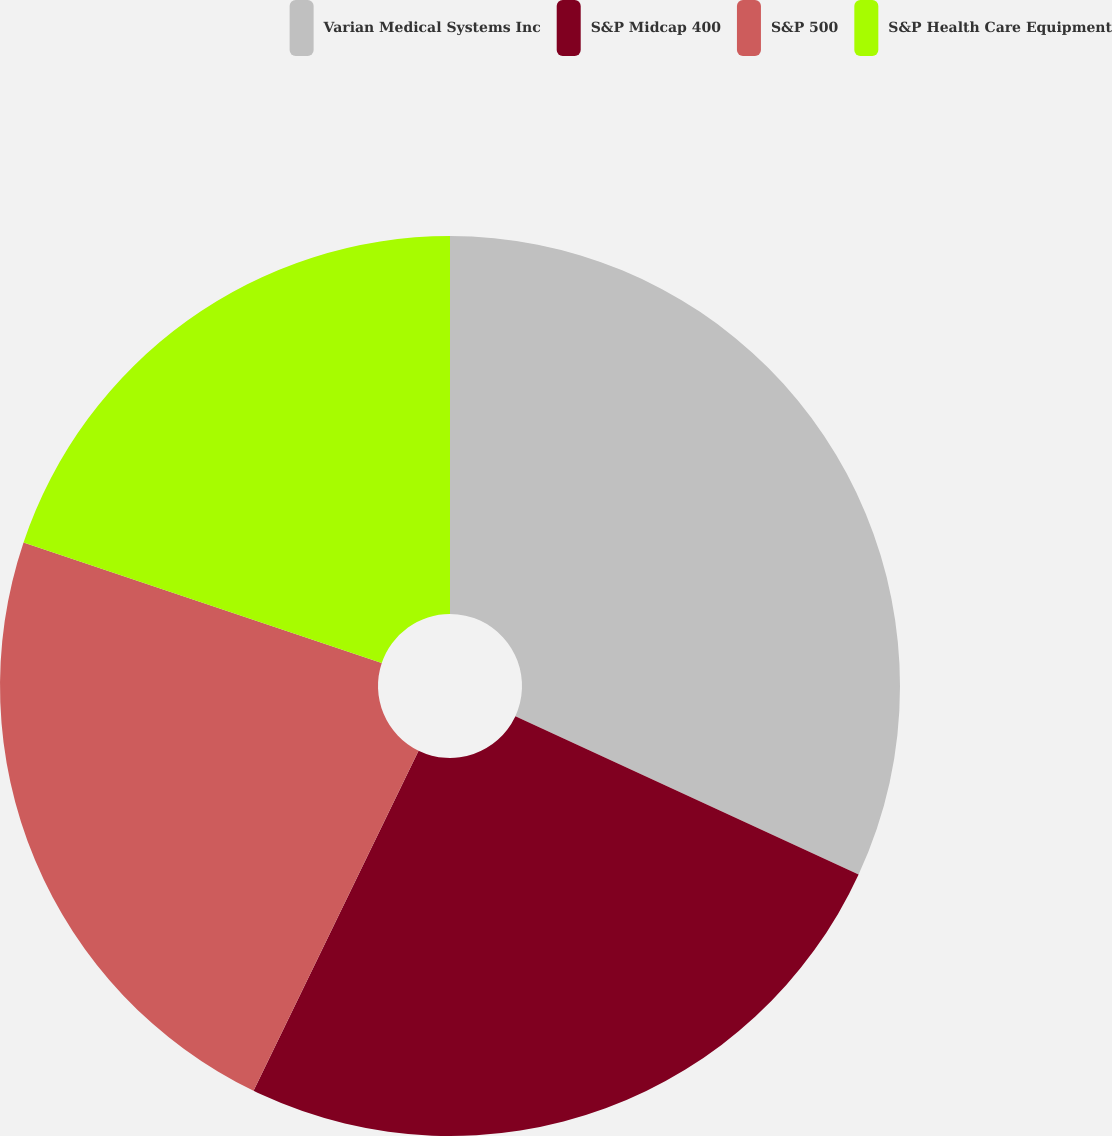Convert chart. <chart><loc_0><loc_0><loc_500><loc_500><pie_chart><fcel>Varian Medical Systems Inc<fcel>S&P Midcap 400<fcel>S&P 500<fcel>S&P Health Care Equipment<nl><fcel>31.88%<fcel>25.31%<fcel>22.98%<fcel>19.83%<nl></chart> 